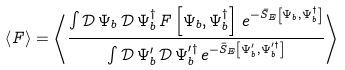Convert formula to latex. <formula><loc_0><loc_0><loc_500><loc_500>\left \langle F \right \rangle = \left \langle \frac { \int \mathcal { D } \, \Psi _ { b } \, \mathcal { D } \, \Psi _ { b } ^ { \dagger } \, F \left [ \Psi _ { b } , \Psi _ { b } ^ { \dagger } \right ] \, e ^ { - \bar { S } _ { E } \left [ \Psi _ { b } , \Psi _ { b } ^ { \dagger } \right ] } } { \int \mathcal { D } \, \Psi _ { b } ^ { \prime } \, \mathcal { D } \, \Psi _ { b } ^ { \prime \dagger } \, e ^ { - \bar { S } _ { E } \left [ \Psi _ { b } ^ { \prime } , \Psi _ { b } ^ { \prime \dagger } \right ] } } \right \rangle</formula> 